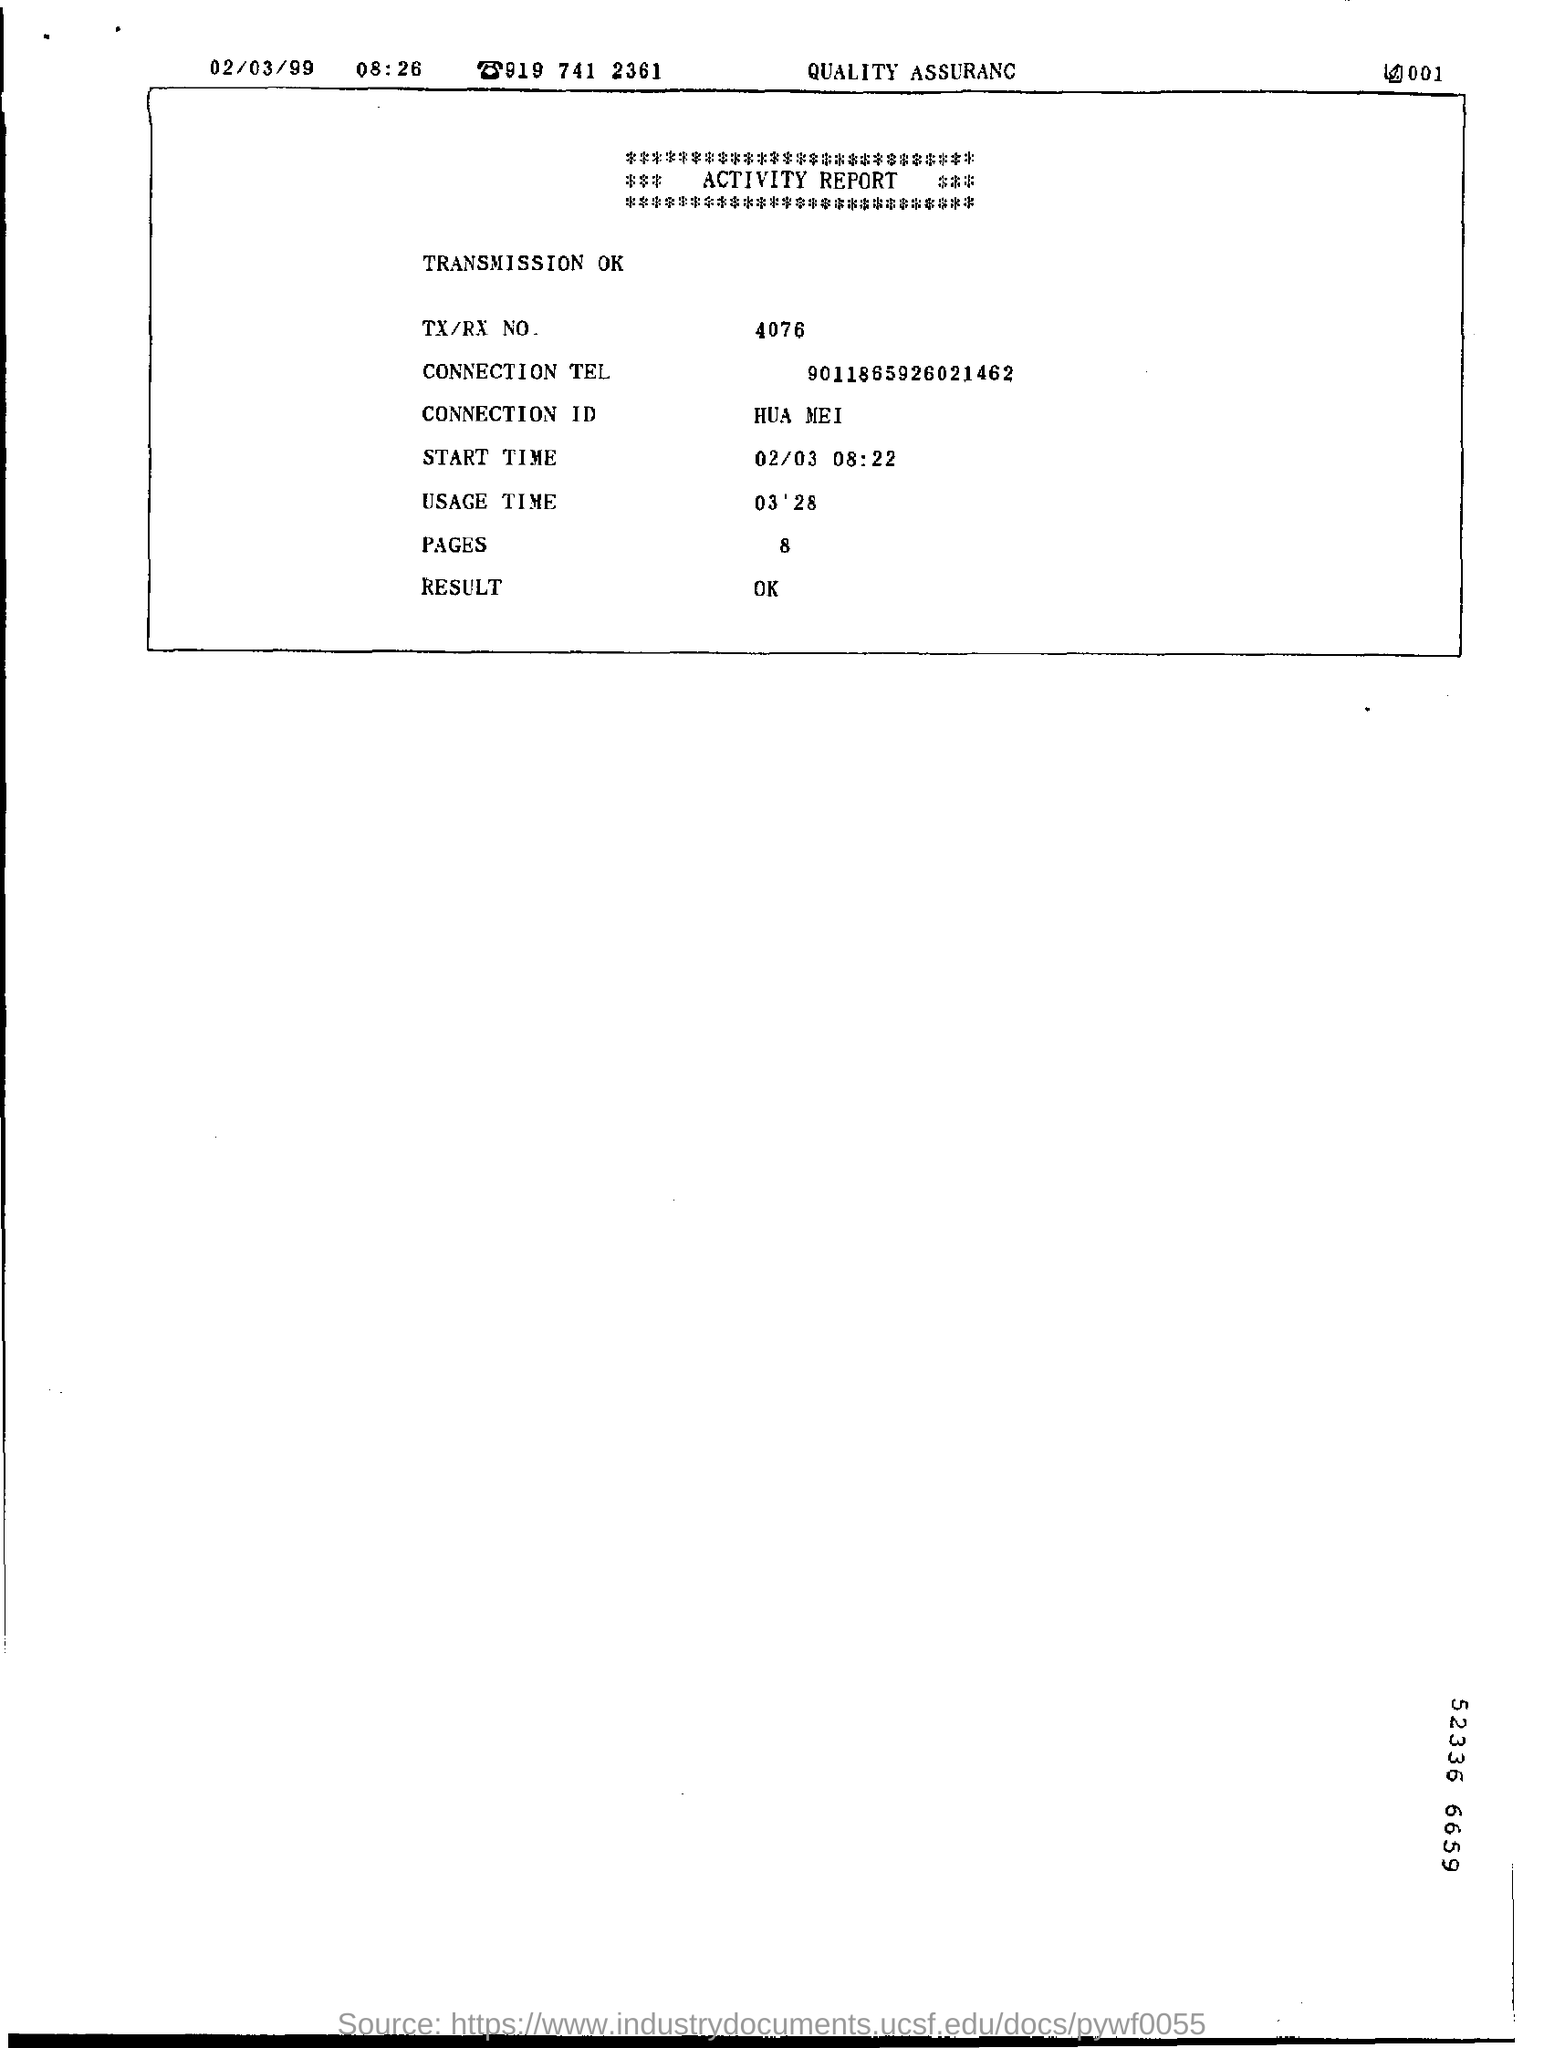What is the TX/RX No given in the Activity Report?
Ensure brevity in your answer.  4076. What is the Connection ID mentioned in the Activity report?
Give a very brief answer. HUA MEI. What is the Connection Tel given in the report?
Offer a terse response. 9011865926021462. 